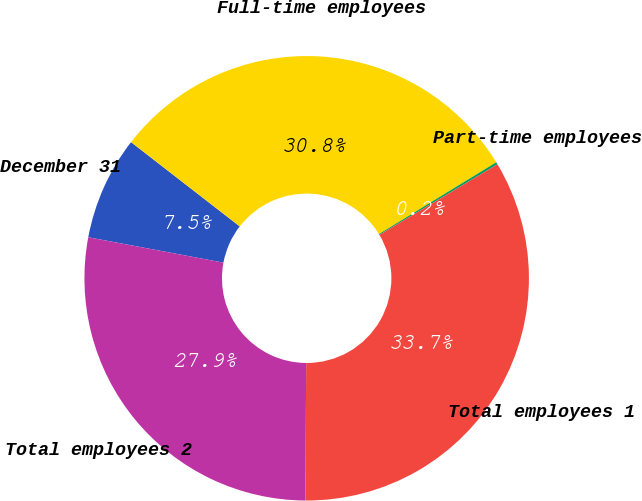Convert chart. <chart><loc_0><loc_0><loc_500><loc_500><pie_chart><fcel>December 31<fcel>Full-time employees<fcel>Part-time employees<fcel>Total employees 1<fcel>Total employees 2<nl><fcel>7.54%<fcel>30.76%<fcel>0.17%<fcel>33.66%<fcel>27.86%<nl></chart> 